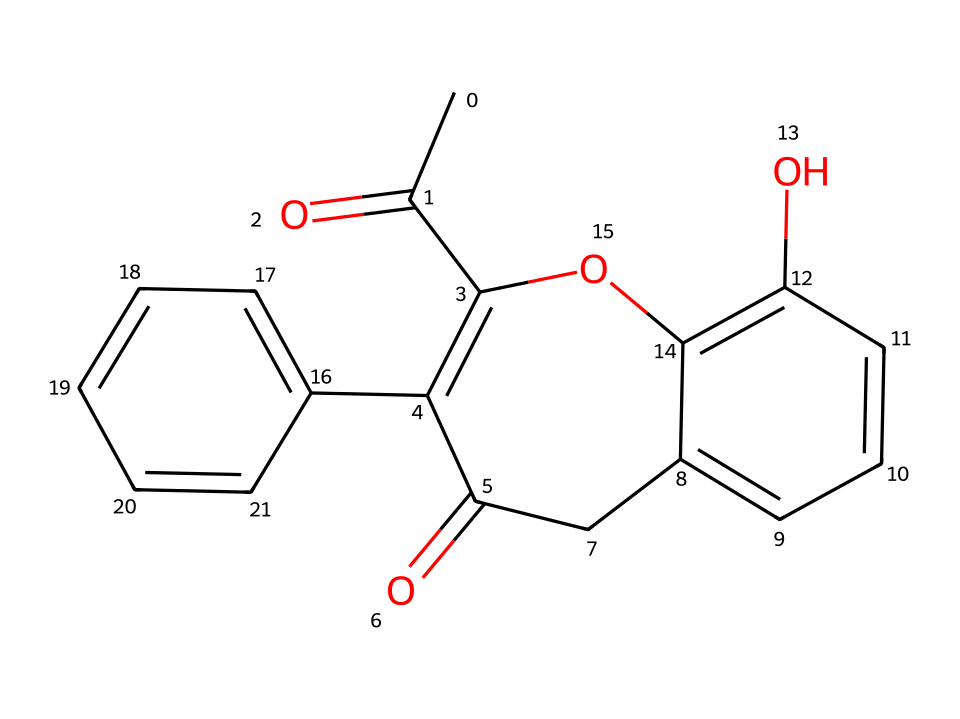What is the molecular formula of warfarin? To deduce the molecular formula from the SMILES notation, one needs to identify the number of each type of atom present in the structure. In this case, counting the carbon (C), hydrogen (H), oxygen (O), we find there are 19 carbons, 16 hydrogens, and 2 oxygens. Therefore, the molecular formula for warfarin is C19H16O4.
Answer: C19H16O4 How many chiral centers are in warfarin? By examining the structure, one assesses the presence of carbon atoms that are attached to four different substituents, as chiral centers must meet this criterion. Warfarin has one such carbon that meets this differentiation; thus, it contains one chiral center.
Answer: 1 What is the main functional group in warfarin? Identifying the functional groups involves looking at the recognizable patterns within the molecule. In warfarin, the presence of the carbonyl group (C=O) signifies a ketone, and the hydroxyl groups (-OH) identify it as a phenolic compound. The main functional group, in this case, is the ketone.
Answer: ketone Which enantiomer of warfarin is more potent? In the context of warfarin, its enantiomers are designated as S-warfarin and R-warfarin. From pharmacological understanding, S-warfarin is known to be the more potent enantiomer influencing the anticoagulant effect significantly more than R-warfarin.
Answer: S-warfarin What type of bond links carbon atoms in warfarin? Analyzing the SMILES and visualizing the structure, the most common type of bonding between carbon atoms in organic molecules such as warfarin is covalent. Specifically, these carbon atoms are primarily linked by single and some double covalent bonds as observed in the structure.
Answer: covalent How many aromatic rings are present in warfarin? To determine the number of aromatic rings, one needs to observe the benzene-like structures within the molecule. Warfarin features two distinct aromatic rings evident in its structure, confirming that there are two aromatic rings present.
Answer: 2 